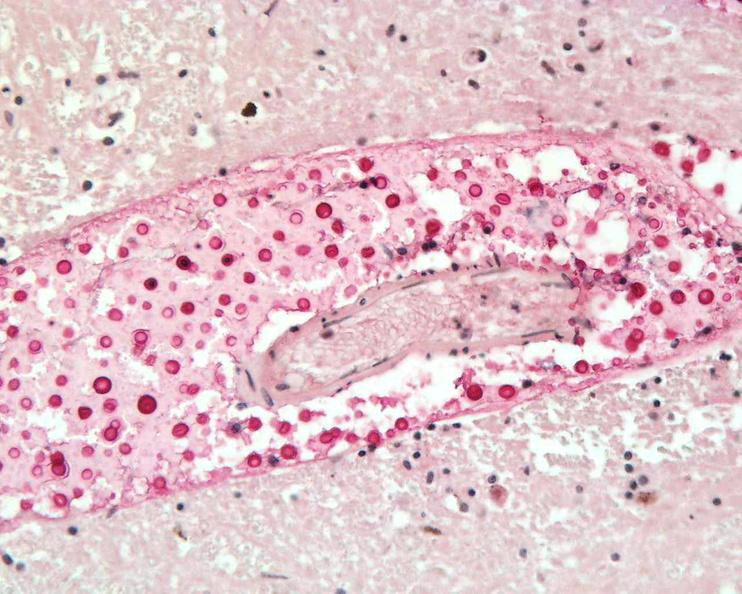does this image show brain, cryptococcal meningitis?
Answer the question using a single word or phrase. Yes 